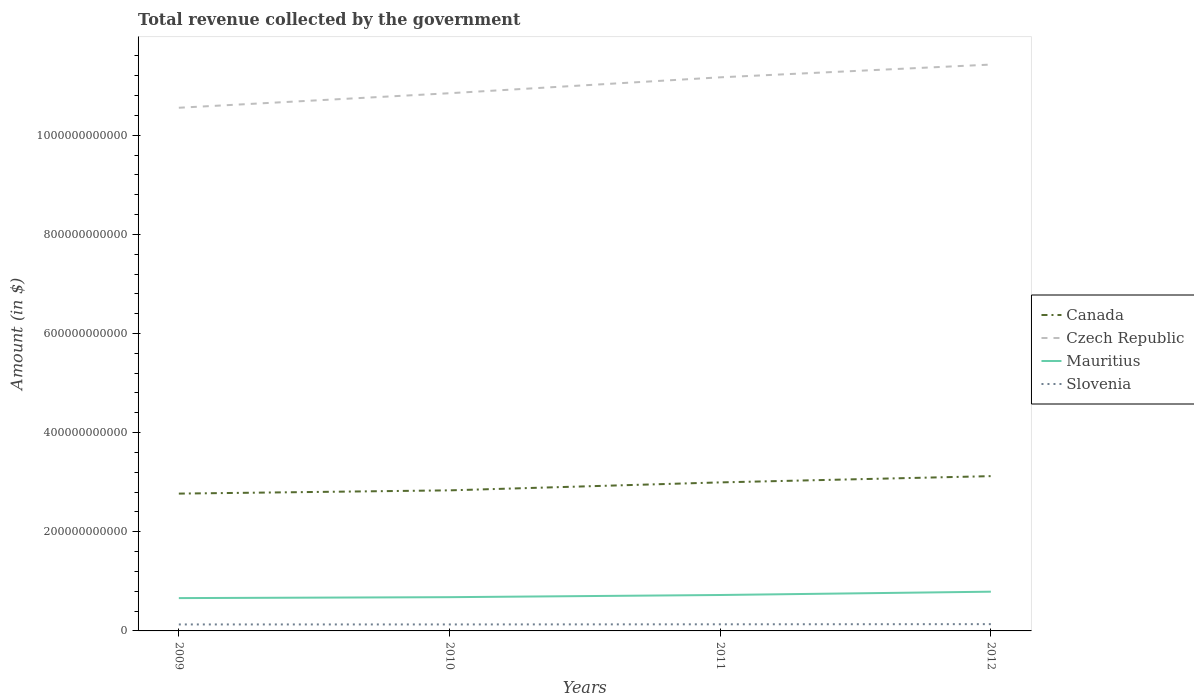Does the line corresponding to Mauritius intersect with the line corresponding to Canada?
Your response must be concise. No. Is the number of lines equal to the number of legend labels?
Offer a very short reply. Yes. Across all years, what is the maximum total revenue collected by the government in Slovenia?
Your answer should be very brief. 1.31e+1. In which year was the total revenue collected by the government in Canada maximum?
Your response must be concise. 2009. What is the total total revenue collected by the government in Slovenia in the graph?
Offer a terse response. -2.78e+08. What is the difference between the highest and the second highest total revenue collected by the government in Canada?
Provide a short and direct response. 3.52e+1. How many lines are there?
Keep it short and to the point. 4. How many years are there in the graph?
Provide a short and direct response. 4. What is the difference between two consecutive major ticks on the Y-axis?
Your answer should be very brief. 2.00e+11. Does the graph contain any zero values?
Provide a succinct answer. No. Does the graph contain grids?
Keep it short and to the point. No. Where does the legend appear in the graph?
Provide a short and direct response. Center right. How are the legend labels stacked?
Offer a terse response. Vertical. What is the title of the graph?
Offer a very short reply. Total revenue collected by the government. Does "Fiji" appear as one of the legend labels in the graph?
Your answer should be compact. No. What is the label or title of the Y-axis?
Provide a short and direct response. Amount (in $). What is the Amount (in $) of Canada in 2009?
Provide a succinct answer. 2.77e+11. What is the Amount (in $) in Czech Republic in 2009?
Provide a short and direct response. 1.06e+12. What is the Amount (in $) of Mauritius in 2009?
Provide a short and direct response. 6.62e+1. What is the Amount (in $) in Slovenia in 2009?
Give a very brief answer. 1.31e+1. What is the Amount (in $) in Canada in 2010?
Provide a short and direct response. 2.84e+11. What is the Amount (in $) of Czech Republic in 2010?
Make the answer very short. 1.08e+12. What is the Amount (in $) of Mauritius in 2010?
Offer a very short reply. 6.81e+1. What is the Amount (in $) in Slovenia in 2010?
Offer a terse response. 1.31e+1. What is the Amount (in $) of Canada in 2011?
Your response must be concise. 3.00e+11. What is the Amount (in $) in Czech Republic in 2011?
Your answer should be compact. 1.12e+12. What is the Amount (in $) in Mauritius in 2011?
Offer a very short reply. 7.25e+1. What is the Amount (in $) of Slovenia in 2011?
Offer a very short reply. 1.34e+1. What is the Amount (in $) in Canada in 2012?
Your answer should be compact. 3.12e+11. What is the Amount (in $) of Czech Republic in 2012?
Offer a very short reply. 1.14e+12. What is the Amount (in $) in Mauritius in 2012?
Offer a very short reply. 7.91e+1. What is the Amount (in $) of Slovenia in 2012?
Offer a terse response. 1.37e+1. Across all years, what is the maximum Amount (in $) of Canada?
Provide a succinct answer. 3.12e+11. Across all years, what is the maximum Amount (in $) of Czech Republic?
Make the answer very short. 1.14e+12. Across all years, what is the maximum Amount (in $) in Mauritius?
Offer a very short reply. 7.91e+1. Across all years, what is the maximum Amount (in $) of Slovenia?
Give a very brief answer. 1.37e+1. Across all years, what is the minimum Amount (in $) in Canada?
Make the answer very short. 2.77e+11. Across all years, what is the minimum Amount (in $) of Czech Republic?
Ensure brevity in your answer.  1.06e+12. Across all years, what is the minimum Amount (in $) of Mauritius?
Keep it short and to the point. 6.62e+1. Across all years, what is the minimum Amount (in $) of Slovenia?
Offer a terse response. 1.31e+1. What is the total Amount (in $) in Canada in the graph?
Provide a succinct answer. 1.17e+12. What is the total Amount (in $) in Czech Republic in the graph?
Provide a short and direct response. 4.40e+12. What is the total Amount (in $) in Mauritius in the graph?
Provide a short and direct response. 2.86e+11. What is the total Amount (in $) of Slovenia in the graph?
Offer a very short reply. 5.32e+1. What is the difference between the Amount (in $) in Canada in 2009 and that in 2010?
Keep it short and to the point. -6.57e+09. What is the difference between the Amount (in $) in Czech Republic in 2009 and that in 2010?
Your response must be concise. -2.93e+1. What is the difference between the Amount (in $) in Mauritius in 2009 and that in 2010?
Your response must be concise. -1.85e+09. What is the difference between the Amount (in $) in Slovenia in 2009 and that in 2010?
Keep it short and to the point. 1.26e+07. What is the difference between the Amount (in $) in Canada in 2009 and that in 2011?
Give a very brief answer. -2.26e+1. What is the difference between the Amount (in $) of Czech Republic in 2009 and that in 2011?
Give a very brief answer. -6.14e+1. What is the difference between the Amount (in $) of Mauritius in 2009 and that in 2011?
Your response must be concise. -6.22e+09. What is the difference between the Amount (in $) of Slovenia in 2009 and that in 2011?
Offer a very short reply. -2.66e+08. What is the difference between the Amount (in $) of Canada in 2009 and that in 2012?
Provide a short and direct response. -3.52e+1. What is the difference between the Amount (in $) in Czech Republic in 2009 and that in 2012?
Offer a very short reply. -8.71e+1. What is the difference between the Amount (in $) in Mauritius in 2009 and that in 2012?
Offer a very short reply. -1.29e+1. What is the difference between the Amount (in $) in Slovenia in 2009 and that in 2012?
Provide a succinct answer. -5.93e+08. What is the difference between the Amount (in $) of Canada in 2010 and that in 2011?
Provide a succinct answer. -1.60e+1. What is the difference between the Amount (in $) of Czech Republic in 2010 and that in 2011?
Keep it short and to the point. -3.21e+1. What is the difference between the Amount (in $) of Mauritius in 2010 and that in 2011?
Keep it short and to the point. -4.37e+09. What is the difference between the Amount (in $) of Slovenia in 2010 and that in 2011?
Offer a very short reply. -2.78e+08. What is the difference between the Amount (in $) in Canada in 2010 and that in 2012?
Your response must be concise. -2.87e+1. What is the difference between the Amount (in $) of Czech Republic in 2010 and that in 2012?
Make the answer very short. -5.78e+1. What is the difference between the Amount (in $) of Mauritius in 2010 and that in 2012?
Provide a succinct answer. -1.10e+1. What is the difference between the Amount (in $) in Slovenia in 2010 and that in 2012?
Ensure brevity in your answer.  -6.06e+08. What is the difference between the Amount (in $) in Canada in 2011 and that in 2012?
Your answer should be very brief. -1.26e+1. What is the difference between the Amount (in $) in Czech Republic in 2011 and that in 2012?
Provide a short and direct response. -2.57e+1. What is the difference between the Amount (in $) of Mauritius in 2011 and that in 2012?
Make the answer very short. -6.68e+09. What is the difference between the Amount (in $) of Slovenia in 2011 and that in 2012?
Make the answer very short. -3.27e+08. What is the difference between the Amount (in $) in Canada in 2009 and the Amount (in $) in Czech Republic in 2010?
Your answer should be very brief. -8.08e+11. What is the difference between the Amount (in $) of Canada in 2009 and the Amount (in $) of Mauritius in 2010?
Make the answer very short. 2.09e+11. What is the difference between the Amount (in $) of Canada in 2009 and the Amount (in $) of Slovenia in 2010?
Your response must be concise. 2.64e+11. What is the difference between the Amount (in $) in Czech Republic in 2009 and the Amount (in $) in Mauritius in 2010?
Offer a very short reply. 9.87e+11. What is the difference between the Amount (in $) in Czech Republic in 2009 and the Amount (in $) in Slovenia in 2010?
Make the answer very short. 1.04e+12. What is the difference between the Amount (in $) of Mauritius in 2009 and the Amount (in $) of Slovenia in 2010?
Give a very brief answer. 5.32e+1. What is the difference between the Amount (in $) in Canada in 2009 and the Amount (in $) in Czech Republic in 2011?
Keep it short and to the point. -8.40e+11. What is the difference between the Amount (in $) of Canada in 2009 and the Amount (in $) of Mauritius in 2011?
Your answer should be compact. 2.05e+11. What is the difference between the Amount (in $) of Canada in 2009 and the Amount (in $) of Slovenia in 2011?
Your answer should be compact. 2.64e+11. What is the difference between the Amount (in $) of Czech Republic in 2009 and the Amount (in $) of Mauritius in 2011?
Keep it short and to the point. 9.83e+11. What is the difference between the Amount (in $) in Czech Republic in 2009 and the Amount (in $) in Slovenia in 2011?
Ensure brevity in your answer.  1.04e+12. What is the difference between the Amount (in $) of Mauritius in 2009 and the Amount (in $) of Slovenia in 2011?
Offer a very short reply. 5.29e+1. What is the difference between the Amount (in $) of Canada in 2009 and the Amount (in $) of Czech Republic in 2012?
Give a very brief answer. -8.66e+11. What is the difference between the Amount (in $) of Canada in 2009 and the Amount (in $) of Mauritius in 2012?
Your response must be concise. 1.98e+11. What is the difference between the Amount (in $) in Canada in 2009 and the Amount (in $) in Slovenia in 2012?
Offer a very short reply. 2.63e+11. What is the difference between the Amount (in $) in Czech Republic in 2009 and the Amount (in $) in Mauritius in 2012?
Provide a succinct answer. 9.76e+11. What is the difference between the Amount (in $) of Czech Republic in 2009 and the Amount (in $) of Slovenia in 2012?
Your answer should be very brief. 1.04e+12. What is the difference between the Amount (in $) in Mauritius in 2009 and the Amount (in $) in Slovenia in 2012?
Provide a short and direct response. 5.26e+1. What is the difference between the Amount (in $) of Canada in 2010 and the Amount (in $) of Czech Republic in 2011?
Your response must be concise. -8.33e+11. What is the difference between the Amount (in $) of Canada in 2010 and the Amount (in $) of Mauritius in 2011?
Your response must be concise. 2.11e+11. What is the difference between the Amount (in $) in Canada in 2010 and the Amount (in $) in Slovenia in 2011?
Make the answer very short. 2.70e+11. What is the difference between the Amount (in $) in Czech Republic in 2010 and the Amount (in $) in Mauritius in 2011?
Give a very brief answer. 1.01e+12. What is the difference between the Amount (in $) in Czech Republic in 2010 and the Amount (in $) in Slovenia in 2011?
Your answer should be compact. 1.07e+12. What is the difference between the Amount (in $) of Mauritius in 2010 and the Amount (in $) of Slovenia in 2011?
Offer a terse response. 5.47e+1. What is the difference between the Amount (in $) in Canada in 2010 and the Amount (in $) in Czech Republic in 2012?
Provide a succinct answer. -8.59e+11. What is the difference between the Amount (in $) in Canada in 2010 and the Amount (in $) in Mauritius in 2012?
Keep it short and to the point. 2.04e+11. What is the difference between the Amount (in $) of Canada in 2010 and the Amount (in $) of Slovenia in 2012?
Provide a succinct answer. 2.70e+11. What is the difference between the Amount (in $) in Czech Republic in 2010 and the Amount (in $) in Mauritius in 2012?
Offer a very short reply. 1.01e+12. What is the difference between the Amount (in $) of Czech Republic in 2010 and the Amount (in $) of Slovenia in 2012?
Your answer should be very brief. 1.07e+12. What is the difference between the Amount (in $) in Mauritius in 2010 and the Amount (in $) in Slovenia in 2012?
Keep it short and to the point. 5.44e+1. What is the difference between the Amount (in $) in Canada in 2011 and the Amount (in $) in Czech Republic in 2012?
Your answer should be compact. -8.43e+11. What is the difference between the Amount (in $) of Canada in 2011 and the Amount (in $) of Mauritius in 2012?
Offer a terse response. 2.20e+11. What is the difference between the Amount (in $) in Canada in 2011 and the Amount (in $) in Slovenia in 2012?
Offer a very short reply. 2.86e+11. What is the difference between the Amount (in $) in Czech Republic in 2011 and the Amount (in $) in Mauritius in 2012?
Make the answer very short. 1.04e+12. What is the difference between the Amount (in $) of Czech Republic in 2011 and the Amount (in $) of Slovenia in 2012?
Ensure brevity in your answer.  1.10e+12. What is the difference between the Amount (in $) in Mauritius in 2011 and the Amount (in $) in Slovenia in 2012?
Your answer should be compact. 5.88e+1. What is the average Amount (in $) of Canada per year?
Provide a succinct answer. 2.93e+11. What is the average Amount (in $) of Czech Republic per year?
Ensure brevity in your answer.  1.10e+12. What is the average Amount (in $) of Mauritius per year?
Your answer should be compact. 7.15e+1. What is the average Amount (in $) of Slovenia per year?
Provide a short and direct response. 1.33e+1. In the year 2009, what is the difference between the Amount (in $) in Canada and Amount (in $) in Czech Republic?
Provide a succinct answer. -7.78e+11. In the year 2009, what is the difference between the Amount (in $) in Canada and Amount (in $) in Mauritius?
Your answer should be very brief. 2.11e+11. In the year 2009, what is the difference between the Amount (in $) of Canada and Amount (in $) of Slovenia?
Your answer should be very brief. 2.64e+11. In the year 2009, what is the difference between the Amount (in $) in Czech Republic and Amount (in $) in Mauritius?
Your answer should be compact. 9.89e+11. In the year 2009, what is the difference between the Amount (in $) of Czech Republic and Amount (in $) of Slovenia?
Make the answer very short. 1.04e+12. In the year 2009, what is the difference between the Amount (in $) in Mauritius and Amount (in $) in Slovenia?
Offer a very short reply. 5.32e+1. In the year 2010, what is the difference between the Amount (in $) of Canada and Amount (in $) of Czech Republic?
Make the answer very short. -8.01e+11. In the year 2010, what is the difference between the Amount (in $) of Canada and Amount (in $) of Mauritius?
Give a very brief answer. 2.15e+11. In the year 2010, what is the difference between the Amount (in $) of Canada and Amount (in $) of Slovenia?
Your answer should be very brief. 2.71e+11. In the year 2010, what is the difference between the Amount (in $) in Czech Republic and Amount (in $) in Mauritius?
Offer a very short reply. 1.02e+12. In the year 2010, what is the difference between the Amount (in $) in Czech Republic and Amount (in $) in Slovenia?
Make the answer very short. 1.07e+12. In the year 2010, what is the difference between the Amount (in $) in Mauritius and Amount (in $) in Slovenia?
Your response must be concise. 5.50e+1. In the year 2011, what is the difference between the Amount (in $) of Canada and Amount (in $) of Czech Republic?
Provide a succinct answer. -8.17e+11. In the year 2011, what is the difference between the Amount (in $) of Canada and Amount (in $) of Mauritius?
Your answer should be compact. 2.27e+11. In the year 2011, what is the difference between the Amount (in $) in Canada and Amount (in $) in Slovenia?
Provide a succinct answer. 2.86e+11. In the year 2011, what is the difference between the Amount (in $) of Czech Republic and Amount (in $) of Mauritius?
Ensure brevity in your answer.  1.04e+12. In the year 2011, what is the difference between the Amount (in $) in Czech Republic and Amount (in $) in Slovenia?
Your answer should be very brief. 1.10e+12. In the year 2011, what is the difference between the Amount (in $) in Mauritius and Amount (in $) in Slovenia?
Provide a succinct answer. 5.91e+1. In the year 2012, what is the difference between the Amount (in $) in Canada and Amount (in $) in Czech Republic?
Make the answer very short. -8.30e+11. In the year 2012, what is the difference between the Amount (in $) in Canada and Amount (in $) in Mauritius?
Your response must be concise. 2.33e+11. In the year 2012, what is the difference between the Amount (in $) of Canada and Amount (in $) of Slovenia?
Offer a terse response. 2.99e+11. In the year 2012, what is the difference between the Amount (in $) in Czech Republic and Amount (in $) in Mauritius?
Provide a short and direct response. 1.06e+12. In the year 2012, what is the difference between the Amount (in $) in Czech Republic and Amount (in $) in Slovenia?
Provide a short and direct response. 1.13e+12. In the year 2012, what is the difference between the Amount (in $) in Mauritius and Amount (in $) in Slovenia?
Your response must be concise. 6.55e+1. What is the ratio of the Amount (in $) of Canada in 2009 to that in 2010?
Give a very brief answer. 0.98. What is the ratio of the Amount (in $) in Czech Republic in 2009 to that in 2010?
Provide a short and direct response. 0.97. What is the ratio of the Amount (in $) of Mauritius in 2009 to that in 2010?
Your answer should be compact. 0.97. What is the ratio of the Amount (in $) of Canada in 2009 to that in 2011?
Ensure brevity in your answer.  0.92. What is the ratio of the Amount (in $) in Czech Republic in 2009 to that in 2011?
Offer a very short reply. 0.94. What is the ratio of the Amount (in $) in Mauritius in 2009 to that in 2011?
Offer a very short reply. 0.91. What is the ratio of the Amount (in $) of Slovenia in 2009 to that in 2011?
Provide a succinct answer. 0.98. What is the ratio of the Amount (in $) in Canada in 2009 to that in 2012?
Offer a very short reply. 0.89. What is the ratio of the Amount (in $) of Czech Republic in 2009 to that in 2012?
Give a very brief answer. 0.92. What is the ratio of the Amount (in $) in Mauritius in 2009 to that in 2012?
Make the answer very short. 0.84. What is the ratio of the Amount (in $) of Slovenia in 2009 to that in 2012?
Provide a succinct answer. 0.96. What is the ratio of the Amount (in $) of Canada in 2010 to that in 2011?
Your answer should be very brief. 0.95. What is the ratio of the Amount (in $) of Czech Republic in 2010 to that in 2011?
Your answer should be compact. 0.97. What is the ratio of the Amount (in $) in Mauritius in 2010 to that in 2011?
Provide a short and direct response. 0.94. What is the ratio of the Amount (in $) in Slovenia in 2010 to that in 2011?
Provide a succinct answer. 0.98. What is the ratio of the Amount (in $) in Canada in 2010 to that in 2012?
Keep it short and to the point. 0.91. What is the ratio of the Amount (in $) in Czech Republic in 2010 to that in 2012?
Ensure brevity in your answer.  0.95. What is the ratio of the Amount (in $) in Mauritius in 2010 to that in 2012?
Your response must be concise. 0.86. What is the ratio of the Amount (in $) of Slovenia in 2010 to that in 2012?
Give a very brief answer. 0.96. What is the ratio of the Amount (in $) in Canada in 2011 to that in 2012?
Your answer should be very brief. 0.96. What is the ratio of the Amount (in $) in Czech Republic in 2011 to that in 2012?
Provide a short and direct response. 0.98. What is the ratio of the Amount (in $) in Mauritius in 2011 to that in 2012?
Make the answer very short. 0.92. What is the ratio of the Amount (in $) of Slovenia in 2011 to that in 2012?
Provide a succinct answer. 0.98. What is the difference between the highest and the second highest Amount (in $) of Canada?
Offer a terse response. 1.26e+1. What is the difference between the highest and the second highest Amount (in $) of Czech Republic?
Provide a succinct answer. 2.57e+1. What is the difference between the highest and the second highest Amount (in $) of Mauritius?
Provide a succinct answer. 6.68e+09. What is the difference between the highest and the second highest Amount (in $) in Slovenia?
Offer a very short reply. 3.27e+08. What is the difference between the highest and the lowest Amount (in $) of Canada?
Ensure brevity in your answer.  3.52e+1. What is the difference between the highest and the lowest Amount (in $) of Czech Republic?
Provide a short and direct response. 8.71e+1. What is the difference between the highest and the lowest Amount (in $) of Mauritius?
Make the answer very short. 1.29e+1. What is the difference between the highest and the lowest Amount (in $) in Slovenia?
Keep it short and to the point. 6.06e+08. 